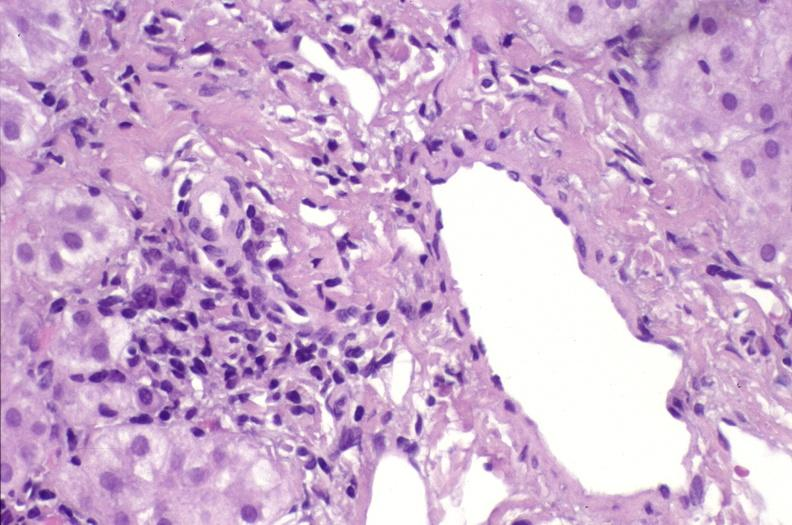does candida in peripheral blood show ductopenia?
Answer the question using a single word or phrase. No 